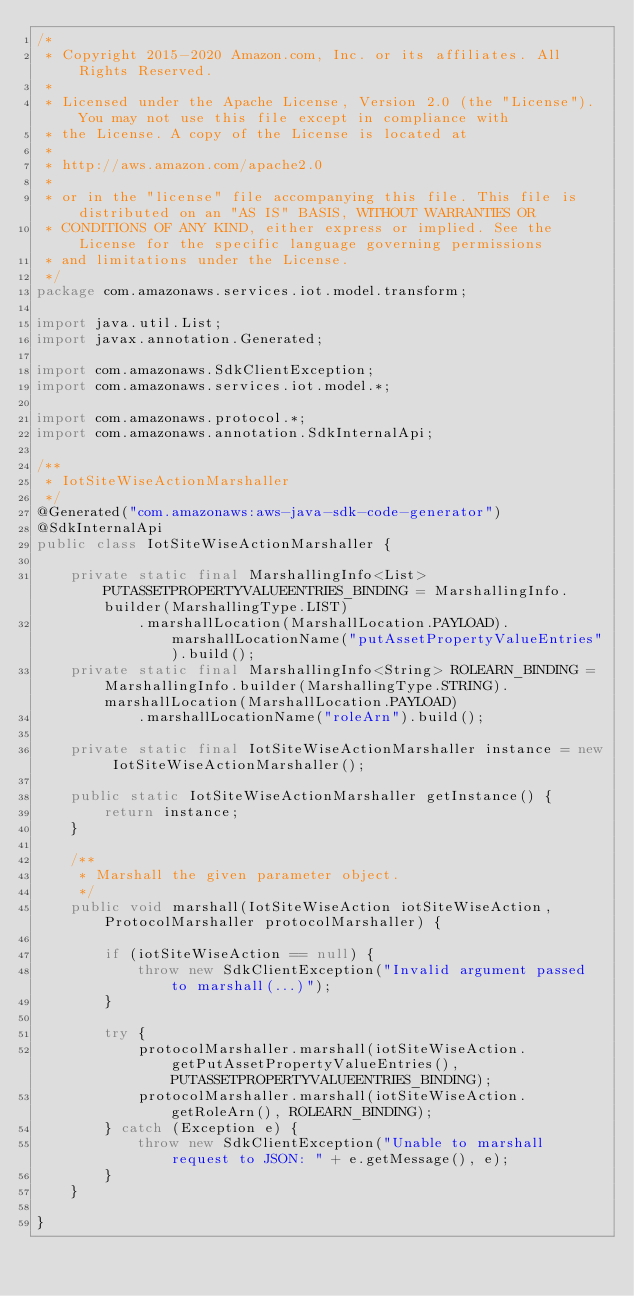<code> <loc_0><loc_0><loc_500><loc_500><_Java_>/*
 * Copyright 2015-2020 Amazon.com, Inc. or its affiliates. All Rights Reserved.
 * 
 * Licensed under the Apache License, Version 2.0 (the "License"). You may not use this file except in compliance with
 * the License. A copy of the License is located at
 * 
 * http://aws.amazon.com/apache2.0
 * 
 * or in the "license" file accompanying this file. This file is distributed on an "AS IS" BASIS, WITHOUT WARRANTIES OR
 * CONDITIONS OF ANY KIND, either express or implied. See the License for the specific language governing permissions
 * and limitations under the License.
 */
package com.amazonaws.services.iot.model.transform;

import java.util.List;
import javax.annotation.Generated;

import com.amazonaws.SdkClientException;
import com.amazonaws.services.iot.model.*;

import com.amazonaws.protocol.*;
import com.amazonaws.annotation.SdkInternalApi;

/**
 * IotSiteWiseActionMarshaller
 */
@Generated("com.amazonaws:aws-java-sdk-code-generator")
@SdkInternalApi
public class IotSiteWiseActionMarshaller {

    private static final MarshallingInfo<List> PUTASSETPROPERTYVALUEENTRIES_BINDING = MarshallingInfo.builder(MarshallingType.LIST)
            .marshallLocation(MarshallLocation.PAYLOAD).marshallLocationName("putAssetPropertyValueEntries").build();
    private static final MarshallingInfo<String> ROLEARN_BINDING = MarshallingInfo.builder(MarshallingType.STRING).marshallLocation(MarshallLocation.PAYLOAD)
            .marshallLocationName("roleArn").build();

    private static final IotSiteWiseActionMarshaller instance = new IotSiteWiseActionMarshaller();

    public static IotSiteWiseActionMarshaller getInstance() {
        return instance;
    }

    /**
     * Marshall the given parameter object.
     */
    public void marshall(IotSiteWiseAction iotSiteWiseAction, ProtocolMarshaller protocolMarshaller) {

        if (iotSiteWiseAction == null) {
            throw new SdkClientException("Invalid argument passed to marshall(...)");
        }

        try {
            protocolMarshaller.marshall(iotSiteWiseAction.getPutAssetPropertyValueEntries(), PUTASSETPROPERTYVALUEENTRIES_BINDING);
            protocolMarshaller.marshall(iotSiteWiseAction.getRoleArn(), ROLEARN_BINDING);
        } catch (Exception e) {
            throw new SdkClientException("Unable to marshall request to JSON: " + e.getMessage(), e);
        }
    }

}
</code> 